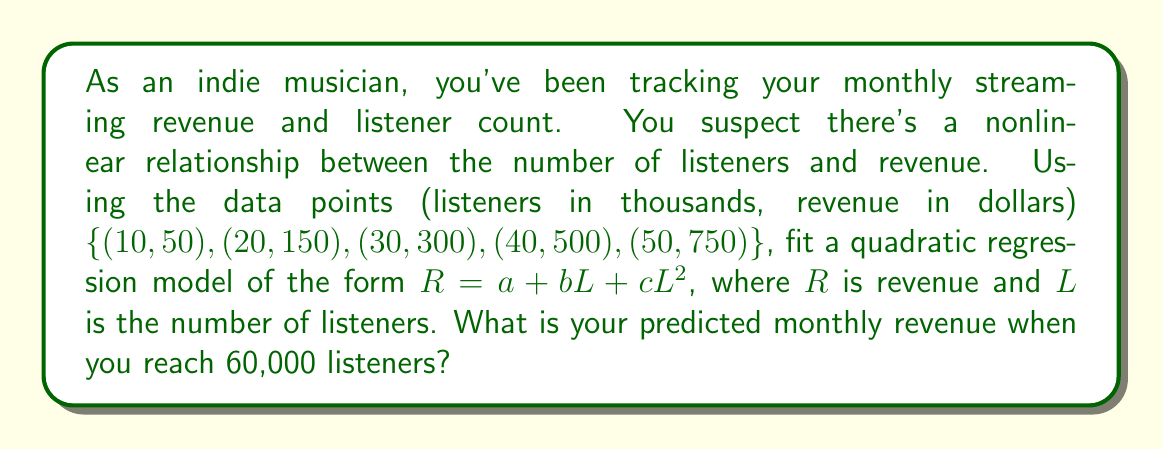Can you solve this math problem? 1. We need to fit the quadratic model $R = a + bL + cL^2$ using the given data points.

2. To find $a$, $b$, and $c$, we'll use the method of least squares. This involves solving the normal equations:

   $$\begin{bmatrix}
   n & \sum L & \sum L^2 \\
   \sum L & \sum L^2 & \sum L^3 \\
   \sum L^2 & \sum L^3 & \sum L^4
   \end{bmatrix}
   \begin{bmatrix}
   a \\
   b \\
   c
   \end{bmatrix} =
   \begin{bmatrix}
   \sum R \\
   \sum LR \\
   \sum L^2R
   \end{bmatrix}$$

3. Calculating the sums:
   $n = 5$
   $\sum L = 150$
   $\sum L^2 = 5500$
   $\sum L^3 = 225000$
   $\sum L^4 = 9750000$
   $\sum R = 1750$
   $\sum LR = 72500$
   $\sum L^2R = 3275000$

4. Substituting into the matrix equation:

   $$\begin{bmatrix}
   5 & 150 & 5500 \\
   150 & 5500 & 225000 \\
   5500 & 225000 & 9750000
   \end{bmatrix}
   \begin{bmatrix}
   a \\
   b \\
   c
   \end{bmatrix} =
   \begin{bmatrix}
   1750 \\
   72500 \\
   3275000
   \end{bmatrix}$$

5. Solving this system of equations (using a computer or calculator) gives:
   $a \approx -41.6667$
   $b \approx 3.5$
   $c \approx 0.25$

6. Our fitted model is: $R \approx -41.6667 + 3.5L + 0.25L^2$

7. To predict revenue for 60,000 listeners, we substitute $L = 60$:
   $R \approx -41.6667 + 3.5(60) + 0.25(60)^2$
   $R \approx -41.6667 + 210 + 900$
   $R \approx 1068.3333$
Answer: $1068.33 